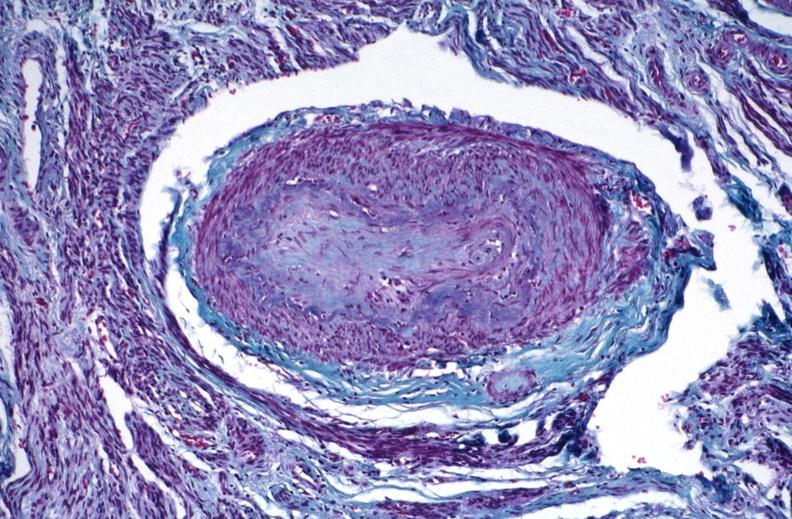where is this?
Answer the question using a single word or phrase. Urinary 